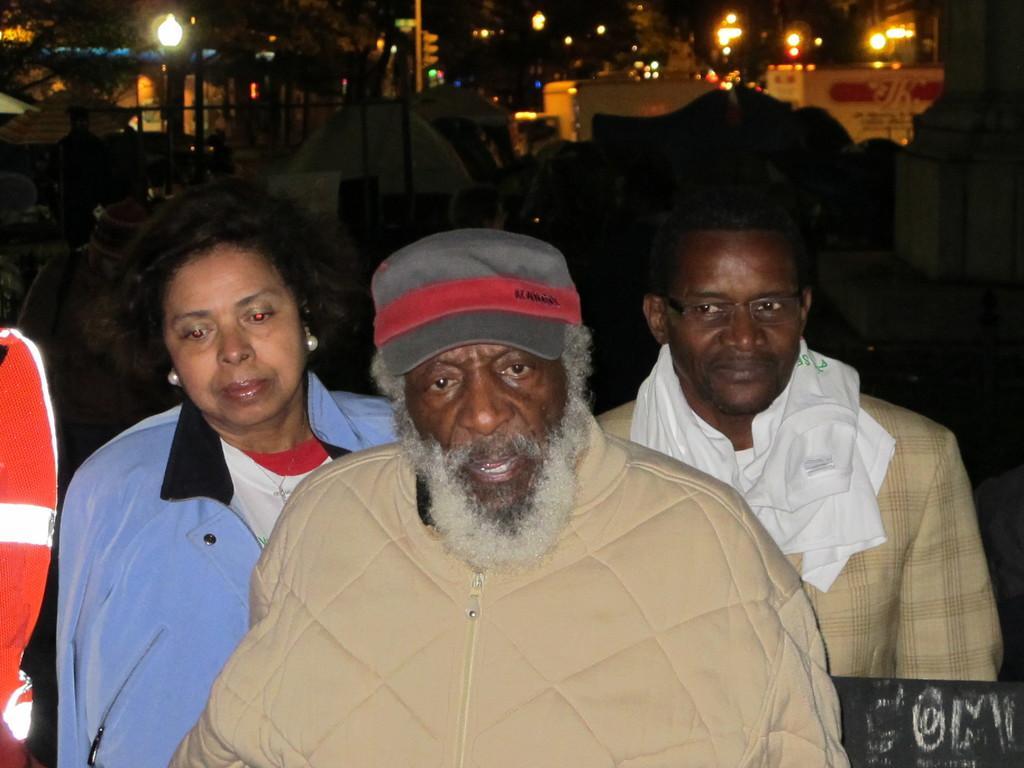In one or two sentences, can you explain what this image depicts? In this image we can see men and a woman. In the background there are buildings, street poles, street lights, trees and tents. 